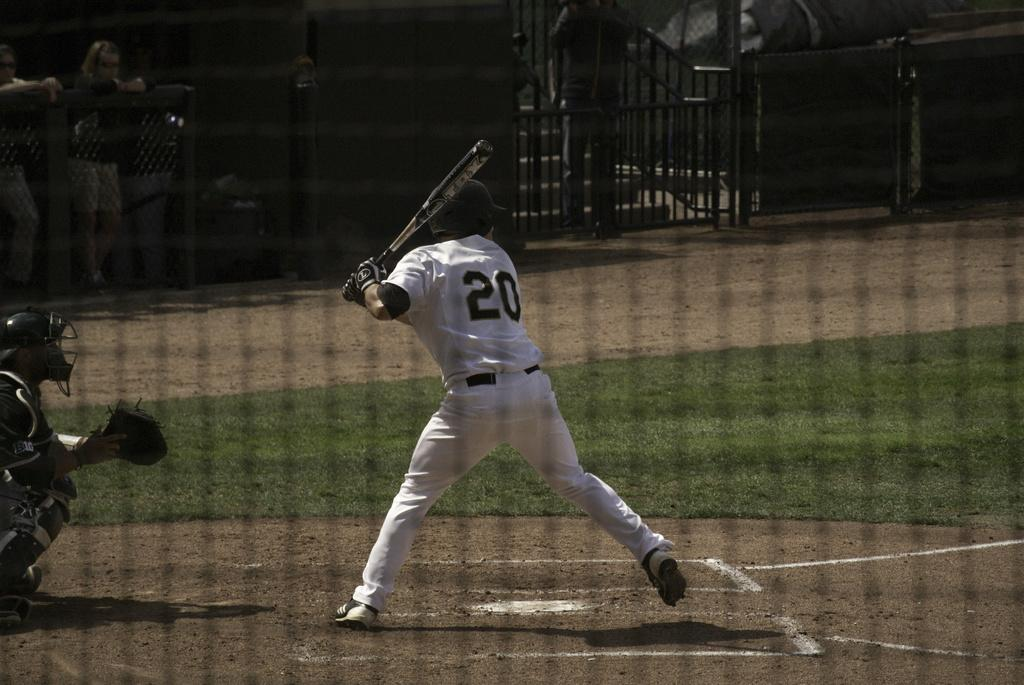<image>
Give a short and clear explanation of the subsequent image. The TPX baseball bat is gripped by the player. 